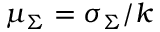Convert formula to latex. <formula><loc_0><loc_0><loc_500><loc_500>\mu _ { \Sigma } = \sigma _ { \Sigma } / k</formula> 